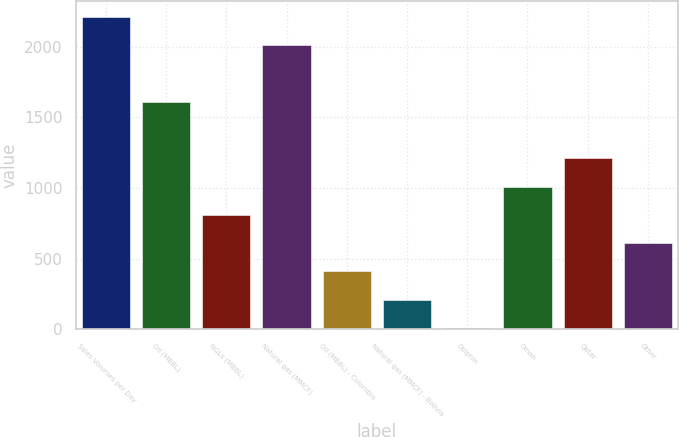Convert chart to OTSL. <chart><loc_0><loc_0><loc_500><loc_500><bar_chart><fcel>Sales Volumes per Day<fcel>Oil (MBBL)<fcel>NGLs (MBBL)<fcel>Natural gas (MMCF)<fcel>Oil (MBBL) - Colombia<fcel>Natural gas (MMCF) - Bolivia<fcel>Dolphin<fcel>Oman<fcel>Qatar<fcel>Other<nl><fcel>2211.2<fcel>1610.6<fcel>809.8<fcel>2011<fcel>409.4<fcel>209.2<fcel>9<fcel>1010<fcel>1210.2<fcel>609.6<nl></chart> 